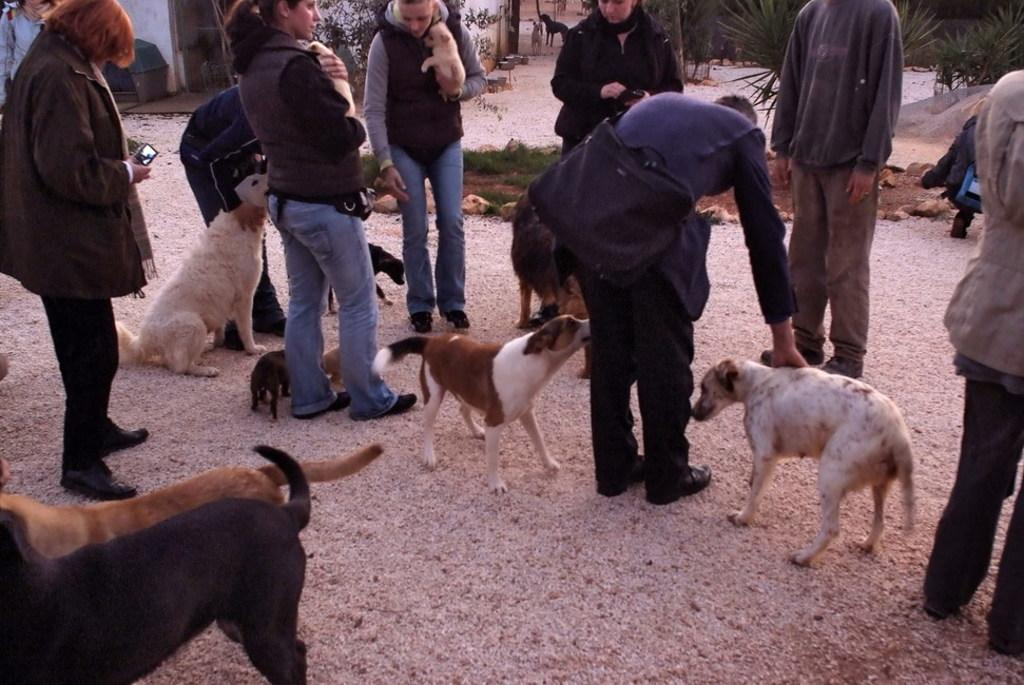What type of animals can be seen in the image? There are dogs in the image. What else is present in the image besides the dogs? There are people standing in the image. What can be seen in the background of the image? There are plants and buildings in the background of the image. Where is the volleyball court located in the image? There is no volleyball court present in the image. What angle is the lunchroom at in the image? There is no lunchroom present in the image. 